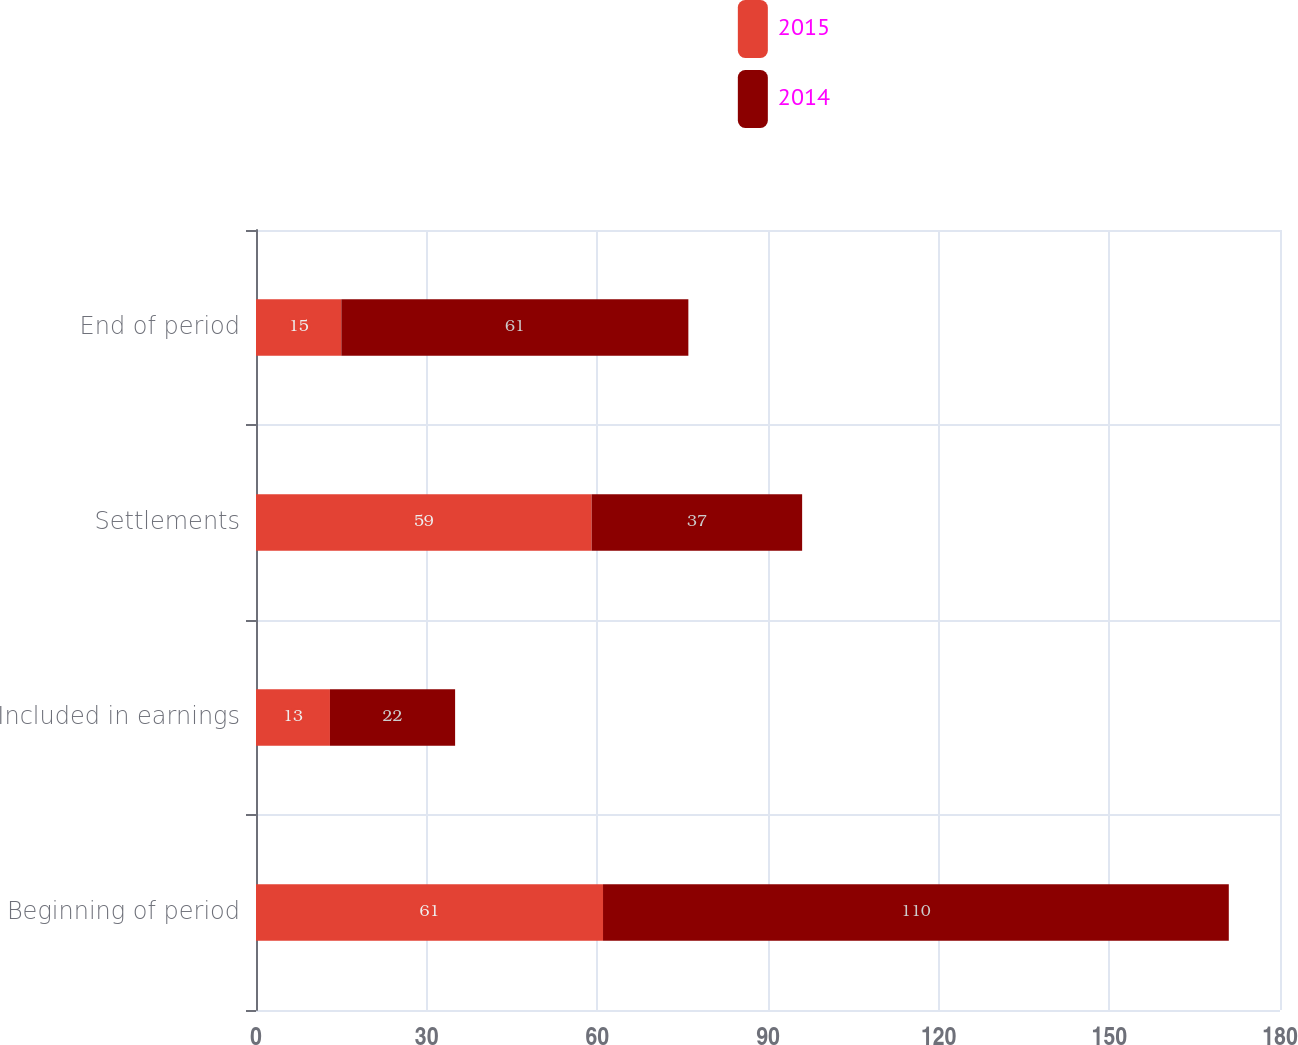Convert chart to OTSL. <chart><loc_0><loc_0><loc_500><loc_500><stacked_bar_chart><ecel><fcel>Beginning of period<fcel>Included in earnings<fcel>Settlements<fcel>End of period<nl><fcel>2015<fcel>61<fcel>13<fcel>59<fcel>15<nl><fcel>2014<fcel>110<fcel>22<fcel>37<fcel>61<nl></chart> 